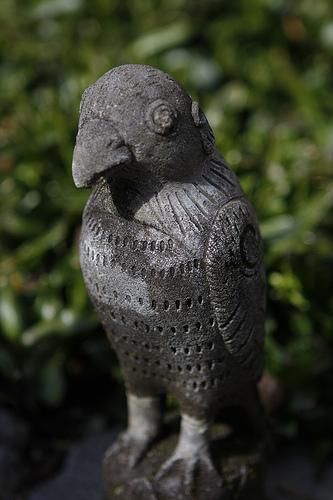How is the bird depicted in the image standing, and what makes it look lifelike or realistic? The bird is depicted in the image standing on its feet, which are placed on a small, round pedestal. The lifelike appearance comes from the detailed black stone carving, including features such as the beak, eye, and etchings on its breast. Imagine this artwork is titled "The Stone Falcon," and provide a simple analysis of it. "The Stone Falcon" is a captivating piece featuring a falcon made from black stone, standing on a round pedestal. The attention to detail, including etchings on the breast and natural foliage in the background, creates an intriguing combination of nature and human craftsmanship. In the image, what is surrounding the feet of the bird statue? The feet of the bird statue are on a small, round pedestal, and it is surrounded by green leaves and foliage, providing a natural setting for the artwork. What is the main focus of the image and what type of bird is it likely? The main focus of the image is a statue of a bird, likely a falcon, made from black stone with intricate etchings and details, such as its beak, wings, and feet. What is behind the statue and how does it contrast with the statue? Green leaves and foliage are behind the statue, providing a contrasting backdrop of natural elements against the man-made stone statue of the bird. Mention a few key elements of the bird statue in the image. The bird statue has a detailed beak, an eye, a wing, and its feet on a pedestal; it also has hatch marks decorating its breast and it's likely made of stone. In a few words, describe the environment where the bird statue is placed. The bird statue is placed in a natural setting, surrounded by green leaves and dense foliage, which contrasts the man-made, black stone artwork. Provide a short summary of the artwork. A statue of a bird, possibly a falcon made of black stone, is depicted with great detail, including etchings on its breast, and it stands on a small, round pedestal surrounded by green leaves in the background. Describe the facial features of the bird statue, such as its beak, eyes, and nostril. The bird statue has a detailed and fierce-looking beak, a distinctive eye and a nostril that all contribute to giving the sculpture a lifelike and intriguing appearance. Describe the materials and colors used for the bird statue. The bird statue appears to be made of stone, possibly black or dark grey in color, with intricate detailing and etchings adding extra features such as patterning on its breast. 